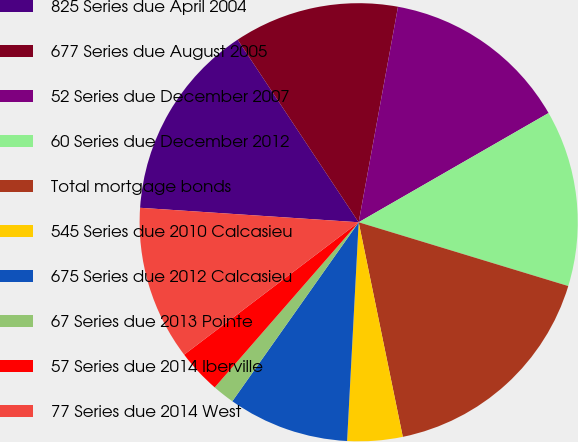Convert chart to OTSL. <chart><loc_0><loc_0><loc_500><loc_500><pie_chart><fcel>825 Series due April 2004<fcel>677 Series due August 2005<fcel>52 Series due December 2007<fcel>60 Series due December 2012<fcel>Total mortgage bonds<fcel>545 Series due 2010 Calcasieu<fcel>675 Series due 2012 Calcasieu<fcel>67 Series due 2013 Pointe<fcel>57 Series due 2014 Iberville<fcel>77 Series due 2014 West<nl><fcel>14.63%<fcel>12.19%<fcel>13.82%<fcel>13.01%<fcel>17.07%<fcel>4.07%<fcel>8.94%<fcel>1.63%<fcel>3.26%<fcel>11.38%<nl></chart> 